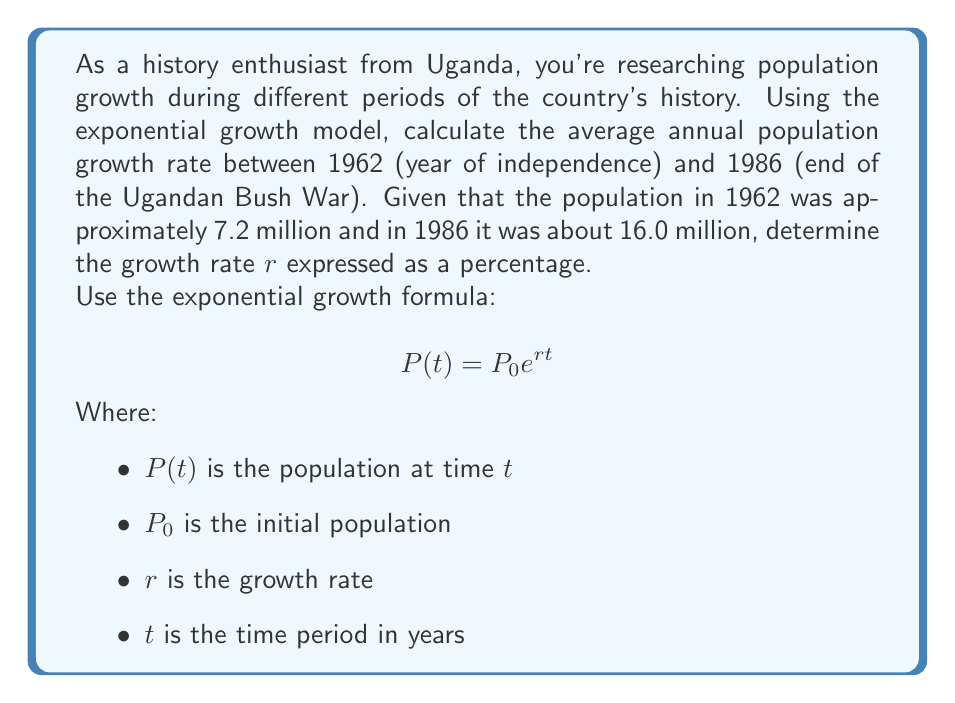Provide a solution to this math problem. To solve this problem, we'll use the exponential growth formula and the given information:

1. Initial population $P_0 = 7.2$ million (1962)
2. Final population $P(t) = 16.0$ million (1986)
3. Time period $t = 1986 - 1962 = 24$ years

Let's substitute these values into the formula:

$$16.0 = 7.2 e^{24r}$$

Now, we'll solve for $r$:

1. Divide both sides by 7.2:
   $$\frac{16.0}{7.2} = e^{24r}$$

2. Take the natural logarithm of both sides:
   $$\ln(\frac{16.0}{7.2}) = \ln(e^{24r})$$

3. Simplify the right side using the properties of logarithms:
   $$\ln(\frac{16.0}{7.2}) = 24r$$

4. Solve for $r$:
   $$r = \frac{\ln(\frac{16.0}{7.2})}{24}$$

5. Calculate the value:
   $$r = \frac{\ln(2.222222)}{24} \approx 0.0334$$

6. Convert to a percentage:
   $$r \approx 3.34\%$$

This growth rate reflects the average annual population increase during a tumultuous period in Uganda's history, including the rule of Idi Amin and the Ugandan Bush War, despite the challenges faced by the population during this time.
Answer: The average annual population growth rate in Uganda between 1962 and 1986 was approximately 3.34%. 